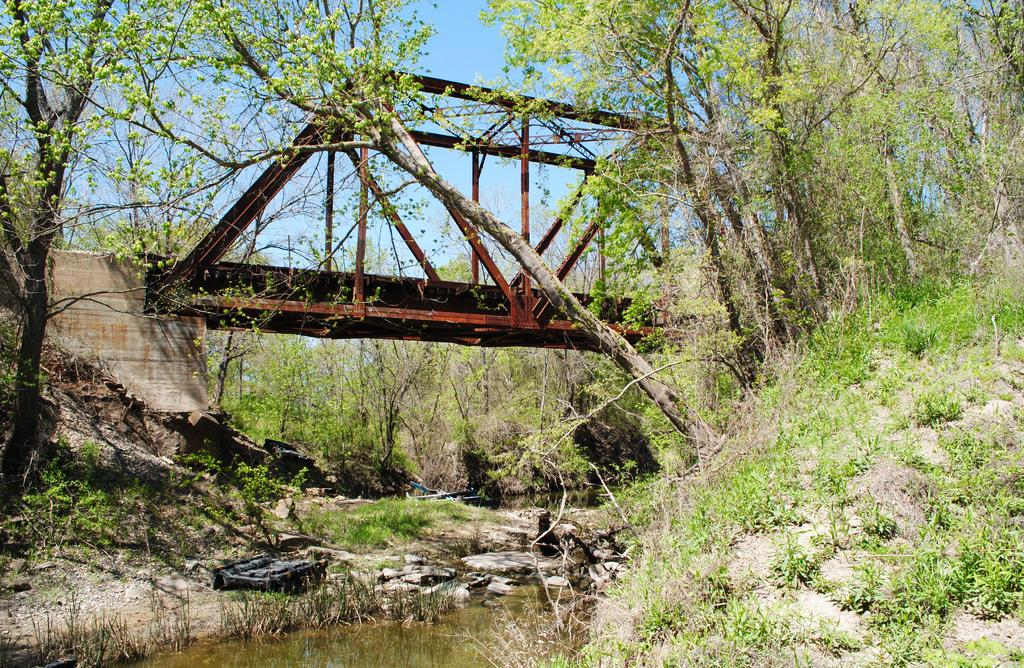What is the primary feature of the image? The primary feature of the image is a water surface. What else can be seen in the image besides the water surface? There is land visible in the image, along with trees. What is located in the background of the image? There is a bridge and the sky visible in the background of the image. Where is the locket hanging in the image? There is no locket present in the image. What type of store can be seen in the background of the image? There is no store visible in the image; it features a water surface, land, trees, a bridge, and the sky. 